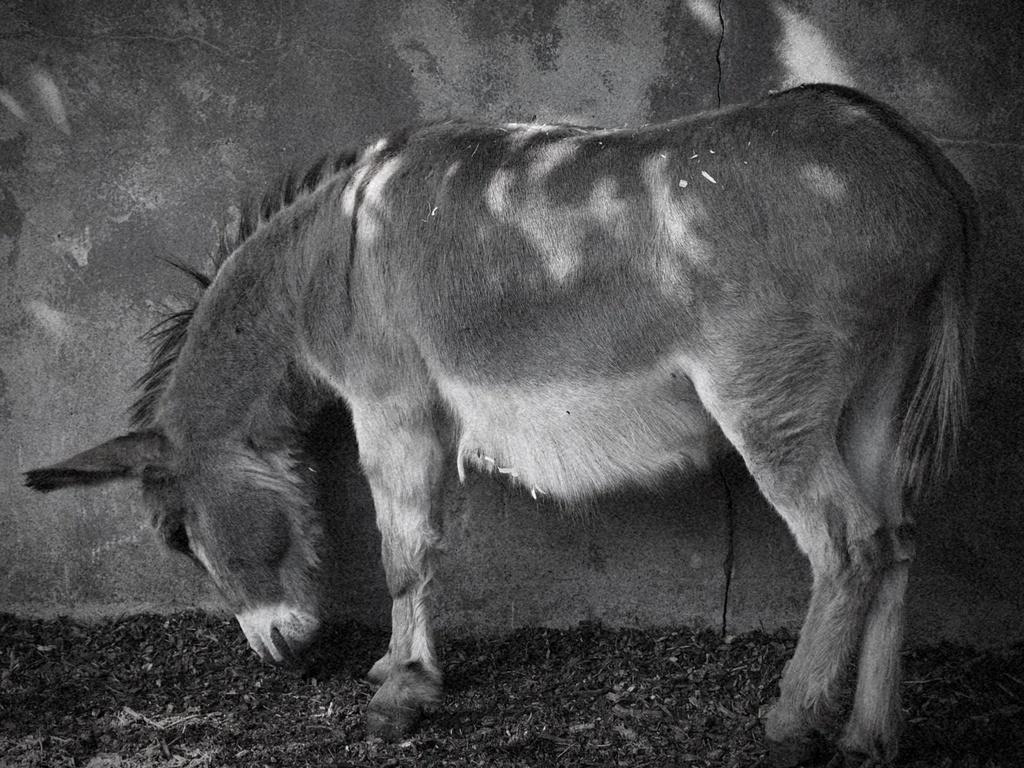In one or two sentences, can you explain what this image depicts? In the image we can see the black and white picture of the donkey and here we can see the wall. 